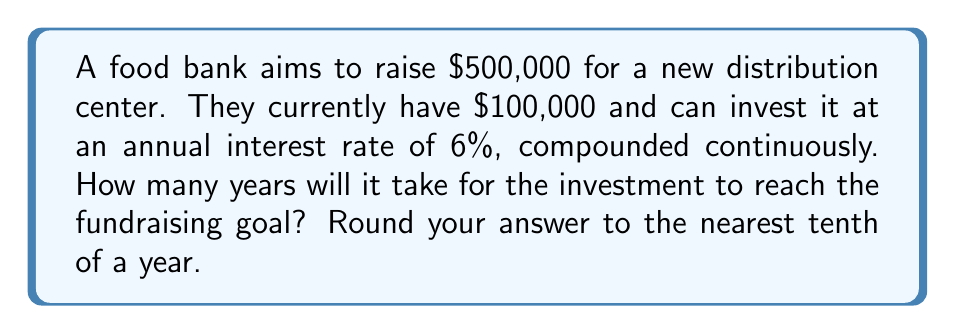What is the answer to this math problem? Let's approach this step-by-step using the continuous compound interest formula and logarithms:

1) The continuous compound interest formula is:
   $A = P e^{rt}$
   where:
   $A$ = final amount
   $P$ = principal (initial investment)
   $r$ = annual interest rate (as a decimal)
   $t$ = time in years
   $e$ = Euler's number (approximately 2.71828)

2) We know:
   $A = \$500,000$ (goal)
   $P = \$100,000$ (initial investment)
   $r = 0.06$ (6% as a decimal)
   We need to solve for $t$.

3) Plugging in the values:
   $500000 = 100000 e^{0.06t}$

4) Divide both sides by 100000:
   $5 = e^{0.06t}$

5) Take the natural logarithm of both sides:
   $\ln(5) = \ln(e^{0.06t})$

6) The natural log and exponential cancel on the right side:
   $\ln(5) = 0.06t$

7) Solve for $t$:
   $t = \frac{\ln(5)}{0.06}$

8) Calculate:
   $t = \frac{\ln(5)}{0.06} \approx 26.9$

9) Rounding to the nearest tenth:
   $t \approx 26.9$ years
Answer: 26.9 years 